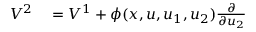Convert formula to latex. <formula><loc_0><loc_0><loc_500><loc_500>\begin{array} { r l } { V ^ { 2 } } & = V ^ { 1 } + \phi ( x , u , u _ { 1 } , u _ { 2 } ) { \frac { \partial } { \partial u _ { 2 } } } } \end{array}</formula> 